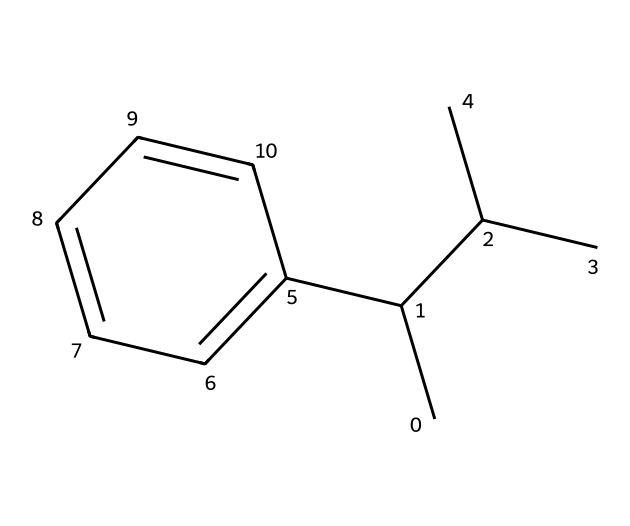What is the molecular formula of this chemical? The SMILES representation indicates the presence of carbon and hydrogen atoms. Counting the carbon atoms (17) and hydrogen atoms (18) gives the molecular formula as C17H18.
Answer: C17H18 How many carbon atoms are present in this structure? By examining the SMILES string, each "C" corresponds to a carbon atom. There are 17 "C" letters in total, indicating the presence of 17 carbon atoms.
Answer: 17 What type of polymer is represented by this structure? Polystyrene is a type of thermoplastic polymer formed from the polymerization of styrene monomers, as indicated by the aromatic ring structure present in the SMILES.
Answer: thermoplastic Does this structure contain any double bonds? The SMILES representation indicates an aromatic system (the "c" indicates sp2 hybridized carbon), which contains double bonds within the ring structure; thus, there are double bonds present.
Answer: yes What functional groups are present in this chemical? Analyzing the structure shows it primarily consists of aromatic and alkyl groups, with no other functional groups such as hydroxyl or carboxyl present. Therefore, the primary functional groups are alkyl and aromatic.
Answer: aromatic and alkyl What is the significance of the bulky substituents in polystyrene's structure? The bulky substituents in polystyrene increase its rigidity and impact resistance, crucial for applications like coffee cup lids which require durability and shape retention.
Answer: increase rigidity and impact resistance How does the structure of polystyrene affect its biodegradability? The structure of polystyrene, being a long hydrocarbon chain with no polar functional groups, makes it resistant to biodegradation, leading to environmental concerns regarding its disposal.
Answer: resistant to biodegradation 